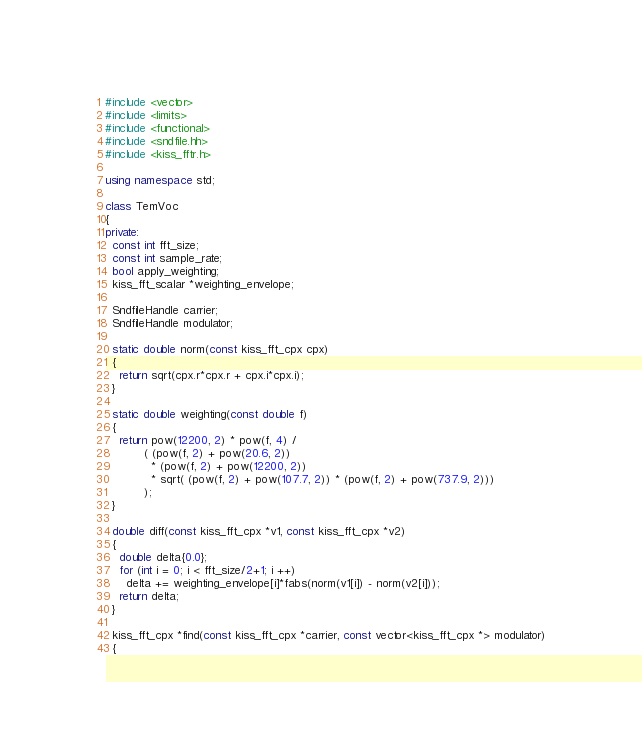<code> <loc_0><loc_0><loc_500><loc_500><_C++_>#include <vector>
#include <limits>
#include <functional>
#include <sndfile.hh>
#include <kiss_fftr.h>

using namespace std;

class TemVoc
{
private:
  const int fft_size;  
  const int sample_rate;
  bool apply_weighting;
  kiss_fft_scalar *weighting_envelope;

  SndfileHandle carrier;
  SndfileHandle modulator;

  static double norm(const kiss_fft_cpx cpx)
  {
    return sqrt(cpx.r*cpx.r + cpx.i*cpx.i);
  }

  static double weighting(const double f)
  {
    return pow(12200, 2) * pow(f, 4) /
           ( (pow(f, 2) + pow(20.6, 2))
             * (pow(f, 2) + pow(12200, 2)) 
             * sqrt( (pow(f, 2) + pow(107.7, 2)) * (pow(f, 2) + pow(737.9, 2)))
           );
  }

  double diff(const kiss_fft_cpx *v1, const kiss_fft_cpx *v2)
  {
    double delta{0.0};
    for (int i = 0; i < fft_size/2+1; i ++)
      delta += weighting_envelope[i]*fabs(norm(v1[i]) - norm(v2[i]));
    return delta;
  }

  kiss_fft_cpx *find(const kiss_fft_cpx *carrier, const vector<kiss_fft_cpx *> modulator)
  {</code> 